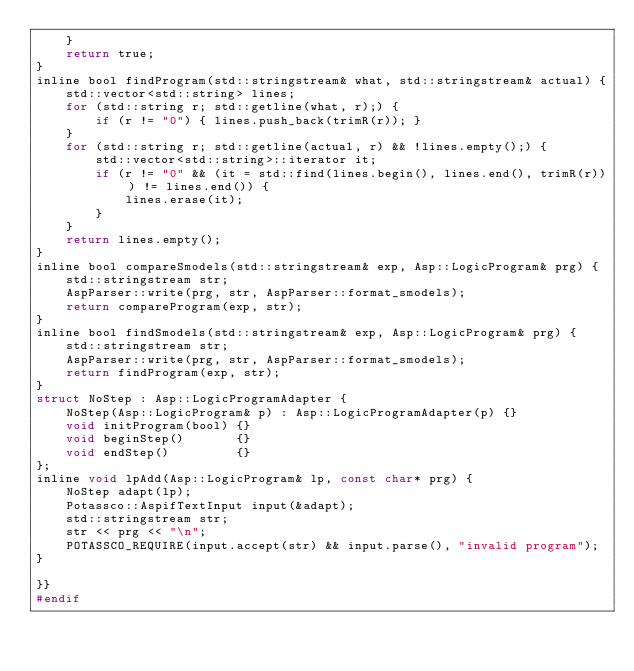Convert code to text. <code><loc_0><loc_0><loc_500><loc_500><_C_>	}
	return true;
}
inline bool findProgram(std::stringstream& what, std::stringstream& actual) {
	std::vector<std::string> lines;
	for (std::string r; std::getline(what, r);) {
		if (r != "0") { lines.push_back(trimR(r)); }
	}
	for (std::string r; std::getline(actual, r) && !lines.empty();) {
		std::vector<std::string>::iterator it;
		if (r != "0" && (it = std::find(lines.begin(), lines.end(), trimR(r))) != lines.end()) {
			lines.erase(it);
		}
	}
	return lines.empty();
}
inline bool compareSmodels(std::stringstream& exp, Asp::LogicProgram& prg) {
	std::stringstream str;
	AspParser::write(prg, str, AspParser::format_smodels);
	return compareProgram(exp, str);
}
inline bool findSmodels(std::stringstream& exp, Asp::LogicProgram& prg) {
	std::stringstream str;
	AspParser::write(prg, str, AspParser::format_smodels);
	return findProgram(exp, str);
}
struct NoStep : Asp::LogicProgramAdapter {
	NoStep(Asp::LogicProgram& p) : Asp::LogicProgramAdapter(p) {}
	void initProgram(bool) {}
	void beginStep()       {}
	void endStep()         {}
};
inline void lpAdd(Asp::LogicProgram& lp, const char* prg) {
	NoStep adapt(lp);
	Potassco::AspifTextInput input(&adapt);
	std::stringstream str;
	str << prg << "\n";
	POTASSCO_REQUIRE(input.accept(str) && input.parse(), "invalid program");
}

}}
#endif
</code> 